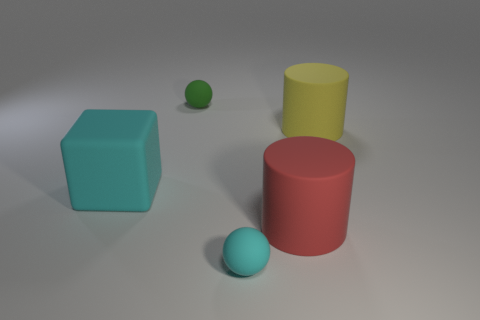Can you describe the scene depicted in the image? Absolutely, the image shows four objects placed on a flat surface with a simple background. There's a tiny green rubber ball, a large turquoise cube, a big red rubber cylinder, and a large yellow rubber cube. The lighting creates soft shadows that add depth to the objects' placement. 